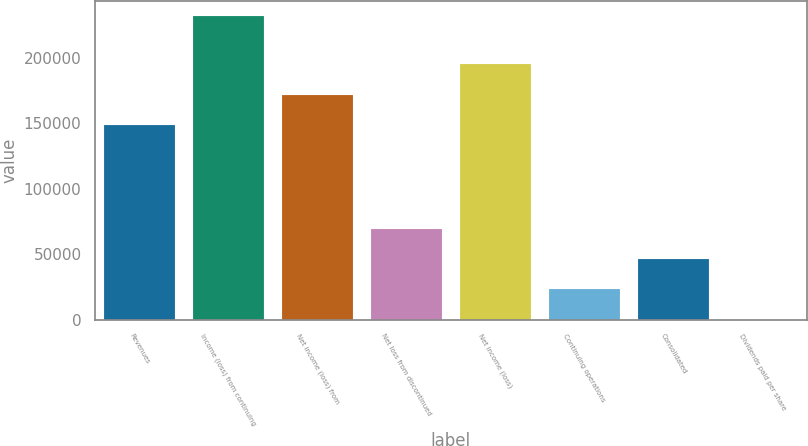<chart> <loc_0><loc_0><loc_500><loc_500><bar_chart><fcel>Revenues<fcel>Income (loss) from continuing<fcel>Net income (loss) from<fcel>Net loss from discontinued<fcel>Net income (loss)<fcel>Continuing operations<fcel>Consolidated<fcel>Dividends paid per share<nl><fcel>148871<fcel>231990<fcel>172070<fcel>69597.2<fcel>195269<fcel>23199.2<fcel>46398.2<fcel>0.25<nl></chart> 